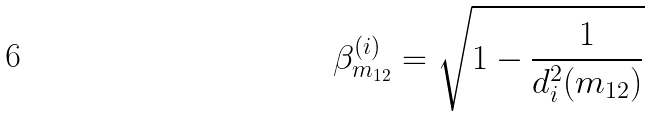<formula> <loc_0><loc_0><loc_500><loc_500>\beta ^ { ( i ) } _ { m _ { 1 2 } } = \sqrt { 1 - \frac { 1 } { d _ { i } ^ { 2 } ( m _ { 1 2 } ) } }</formula> 